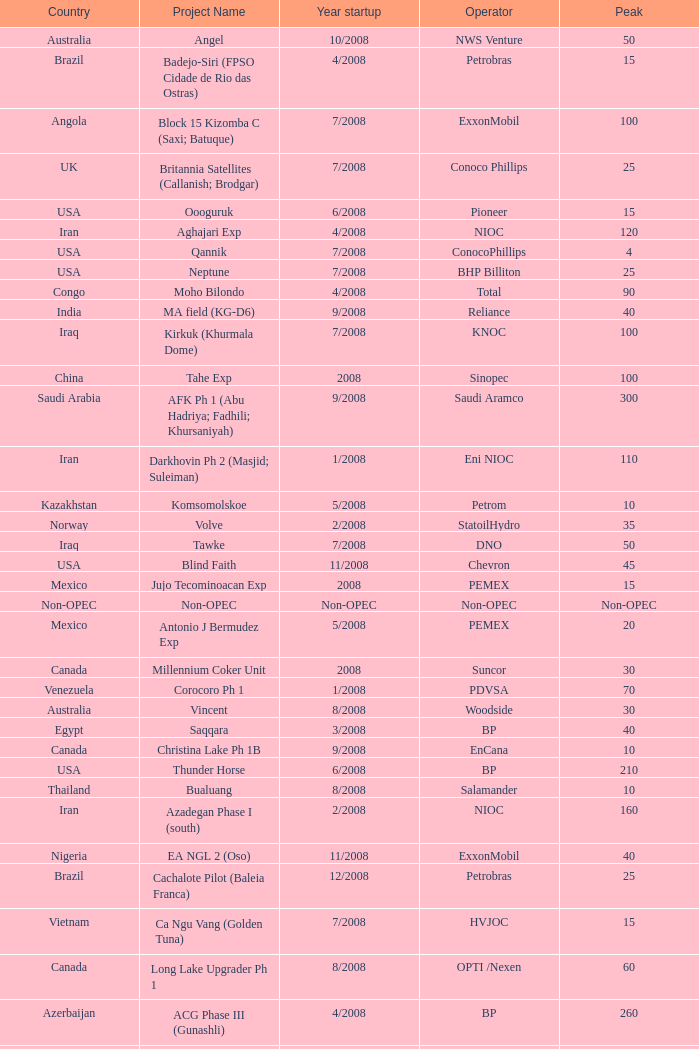What is the Project Name with a Country that is kazakhstan and a Peak that is 150? Dunga. 